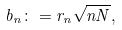Convert formula to latex. <formula><loc_0><loc_0><loc_500><loc_500>b _ { n } \colon = r _ { n } \sqrt { n N } ,</formula> 